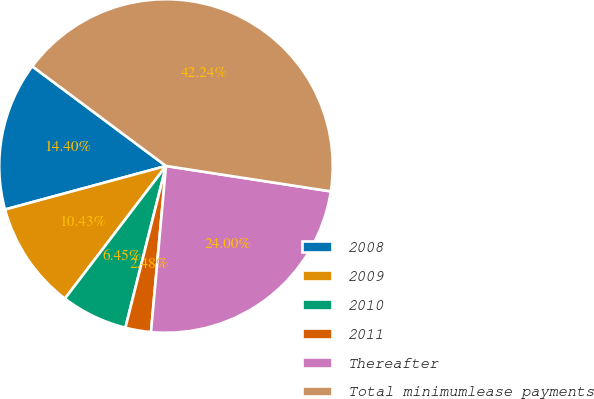Convert chart. <chart><loc_0><loc_0><loc_500><loc_500><pie_chart><fcel>2008<fcel>2009<fcel>2010<fcel>2011<fcel>Thereafter<fcel>Total minimumlease payments<nl><fcel>14.4%<fcel>10.43%<fcel>6.45%<fcel>2.48%<fcel>24.0%<fcel>42.24%<nl></chart> 